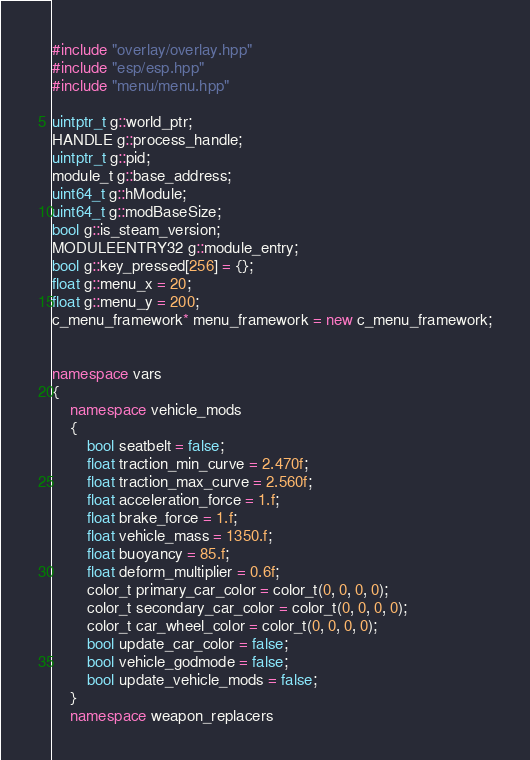<code> <loc_0><loc_0><loc_500><loc_500><_C++_>#include "overlay/overlay.hpp"
#include "esp/esp.hpp"
#include "menu/menu.hpp"

uintptr_t g::world_ptr;
HANDLE g::process_handle;
uintptr_t g::pid;
module_t g::base_address;
uint64_t g::hModule;
uint64_t g::modBaseSize;
bool g::is_steam_version;
MODULEENTRY32 g::module_entry;
bool g::key_pressed[256] = {};
float g::menu_x = 20;
float g::menu_y = 200;
c_menu_framework* menu_framework = new c_menu_framework;


namespace vars
{
	namespace vehicle_mods 
	{
		bool seatbelt = false;
		float traction_min_curve = 2.470f;
		float traction_max_curve = 2.560f;
		float acceleration_force = 1.f;
		float brake_force = 1.f;
		float vehicle_mass = 1350.f;
		float buoyancy = 85.f;
		float deform_multiplier = 0.6f;
		color_t primary_car_color = color_t(0, 0, 0, 0);
		color_t secondary_car_color = color_t(0, 0, 0, 0);
		color_t car_wheel_color = color_t(0, 0, 0, 0);
		bool update_car_color = false;
		bool vehicle_godmode = false;
		bool update_vehicle_mods = false;
	}
	namespace weapon_replacers</code> 